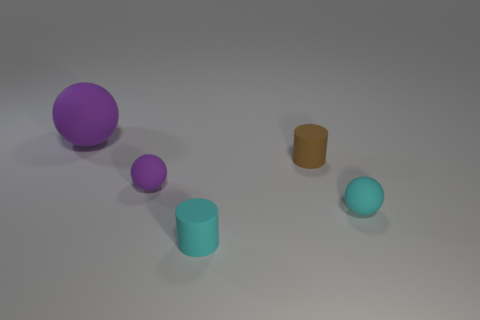What number of tiny cyan objects are there? There are two small cyan objects visible in the image, consisting of a cylinder and a sphere. 